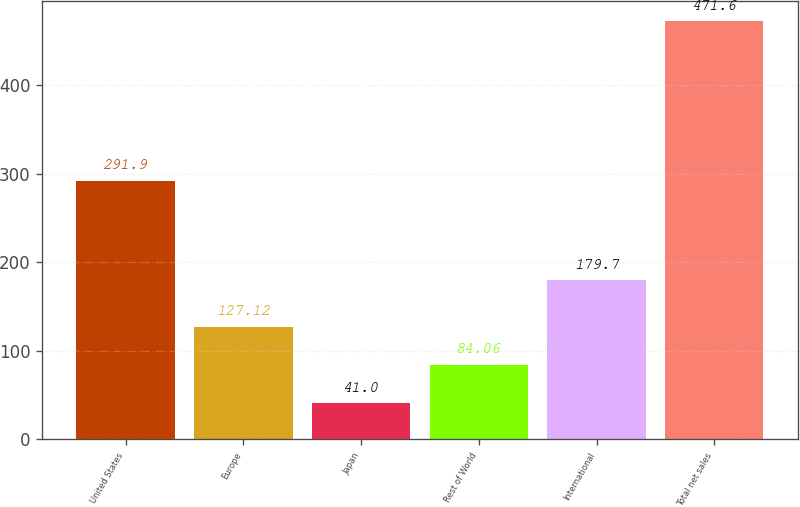<chart> <loc_0><loc_0><loc_500><loc_500><bar_chart><fcel>United States<fcel>Europe<fcel>Japan<fcel>Rest of World<fcel>International<fcel>Total net sales<nl><fcel>291.9<fcel>127.12<fcel>41<fcel>84.06<fcel>179.7<fcel>471.6<nl></chart> 